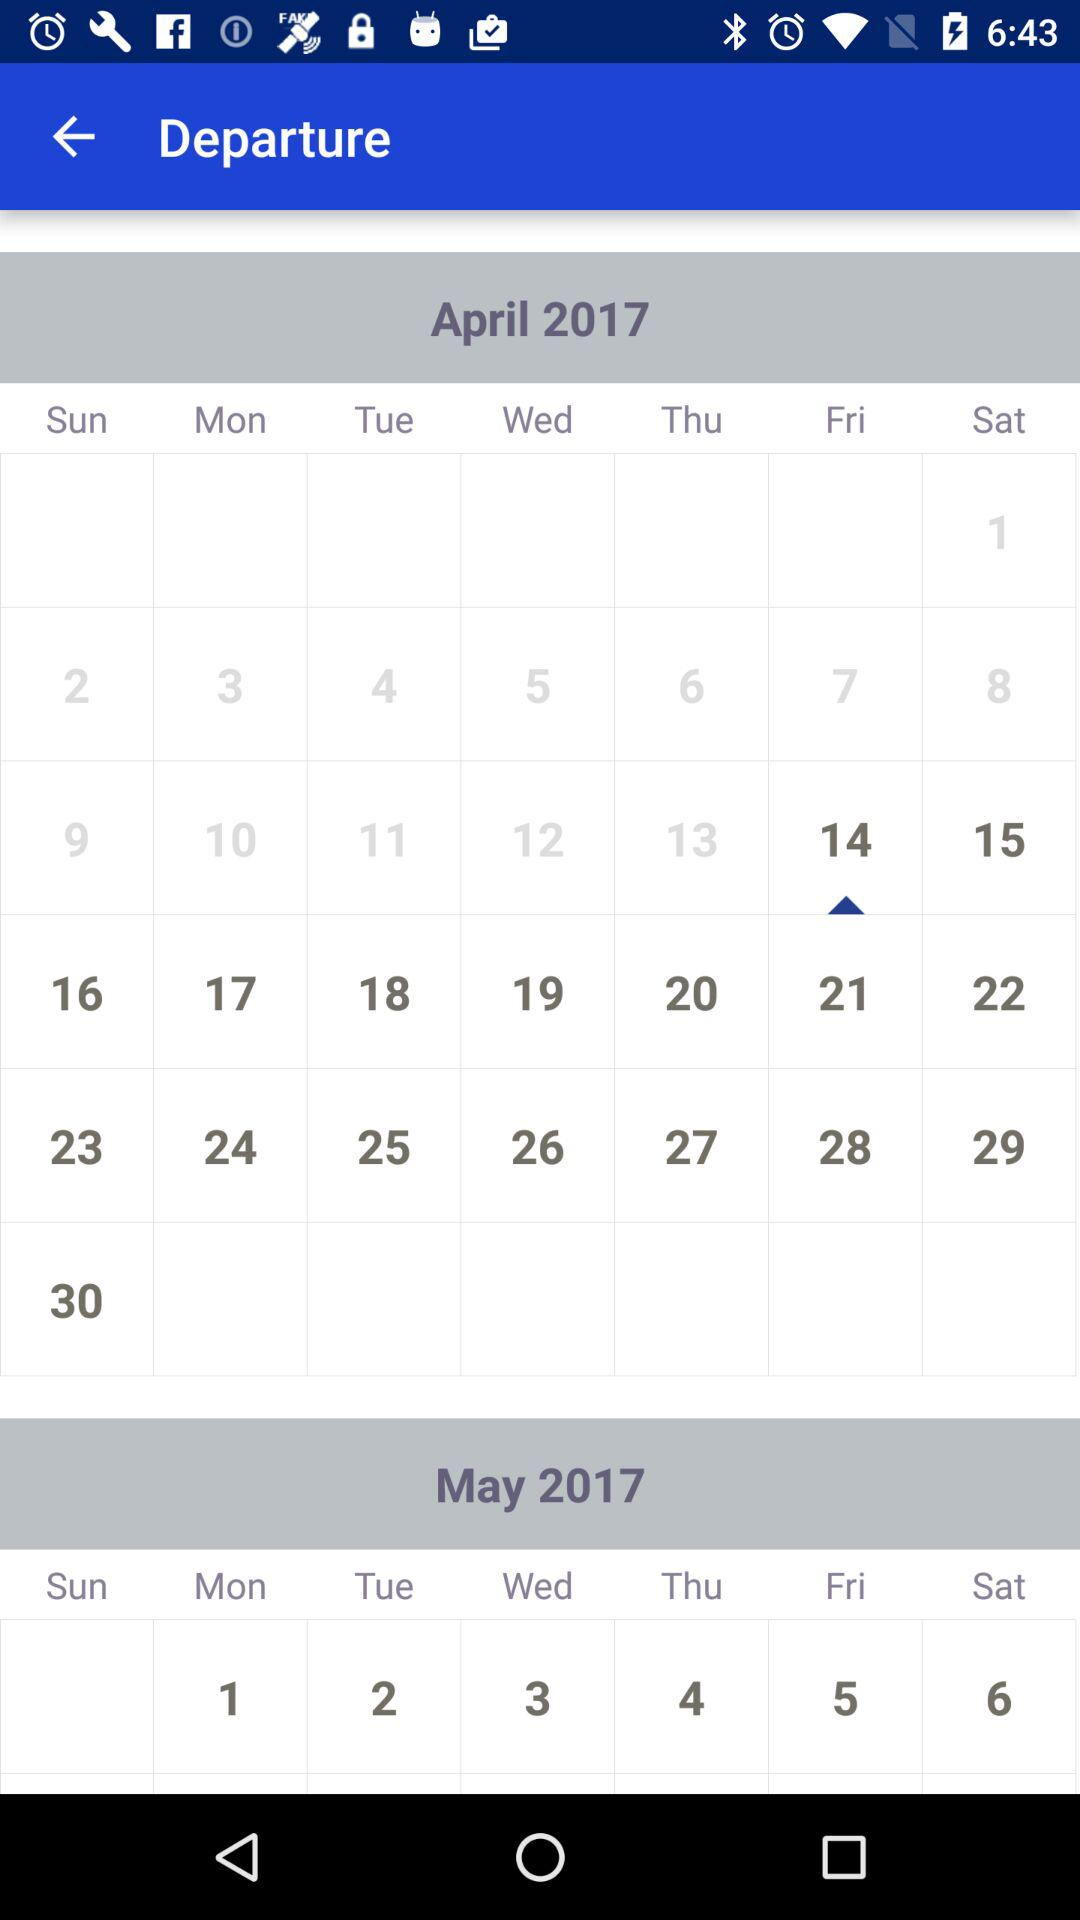What is the present date? The present date is Friday, April 14, 2017. 